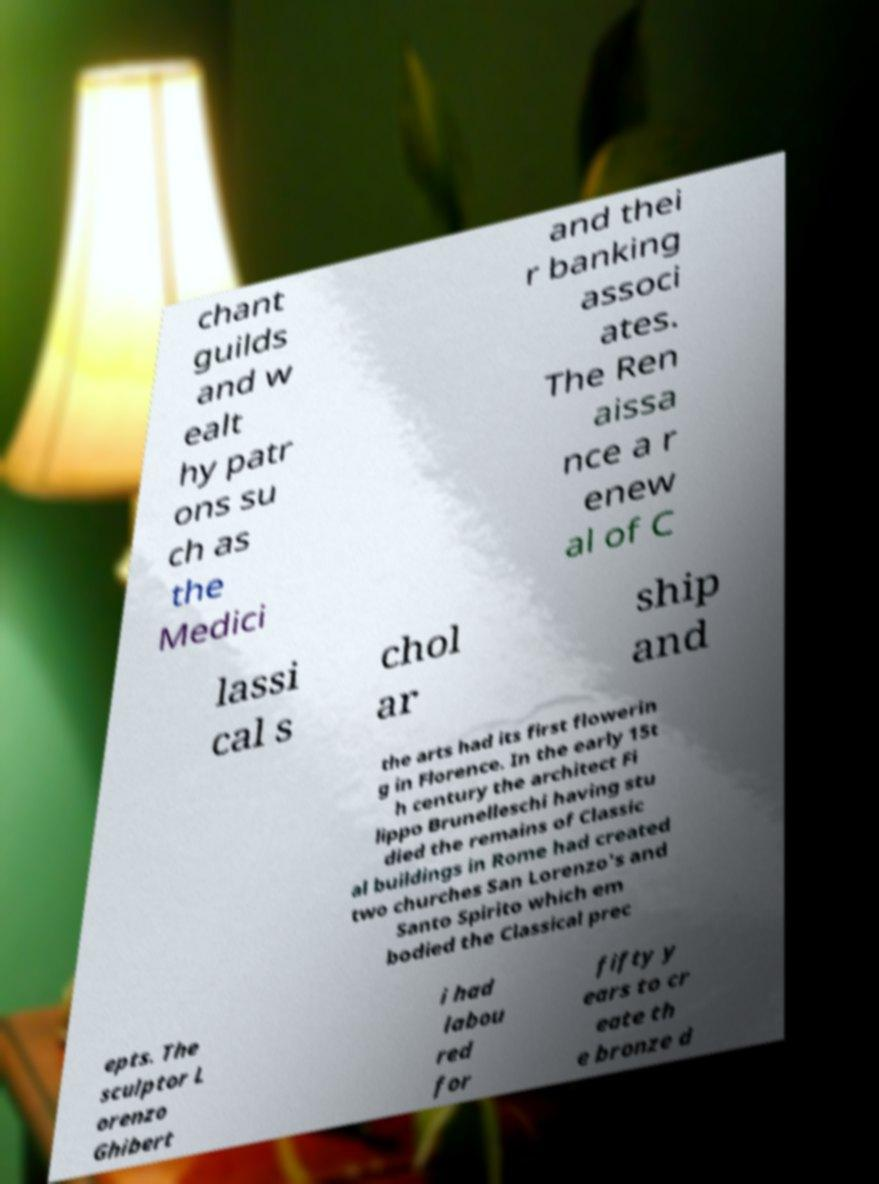Can you read and provide the text displayed in the image?This photo seems to have some interesting text. Can you extract and type it out for me? chant guilds and w ealt hy patr ons su ch as the Medici and thei r banking associ ates. The Ren aissa nce a r enew al of C lassi cal s chol ar ship and the arts had its first flowerin g in Florence. In the early 15t h century the architect Fi lippo Brunelleschi having stu died the remains of Classic al buildings in Rome had created two churches San Lorenzo's and Santo Spirito which em bodied the Classical prec epts. The sculptor L orenzo Ghibert i had labou red for fifty y ears to cr eate th e bronze d 